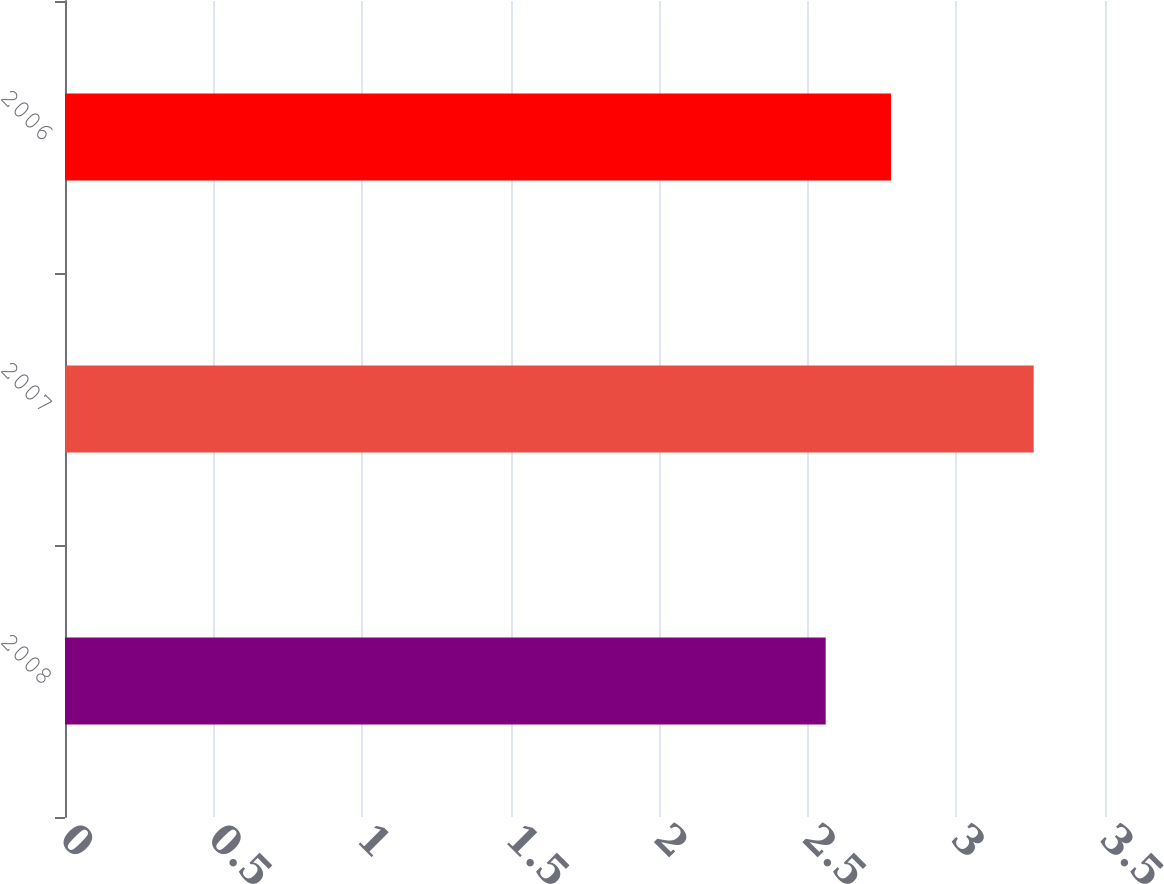Convert chart to OTSL. <chart><loc_0><loc_0><loc_500><loc_500><bar_chart><fcel>2008<fcel>2007<fcel>2006<nl><fcel>2.56<fcel>3.26<fcel>2.78<nl></chart> 